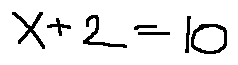<formula> <loc_0><loc_0><loc_500><loc_500>x + 2 = 1 0</formula> 